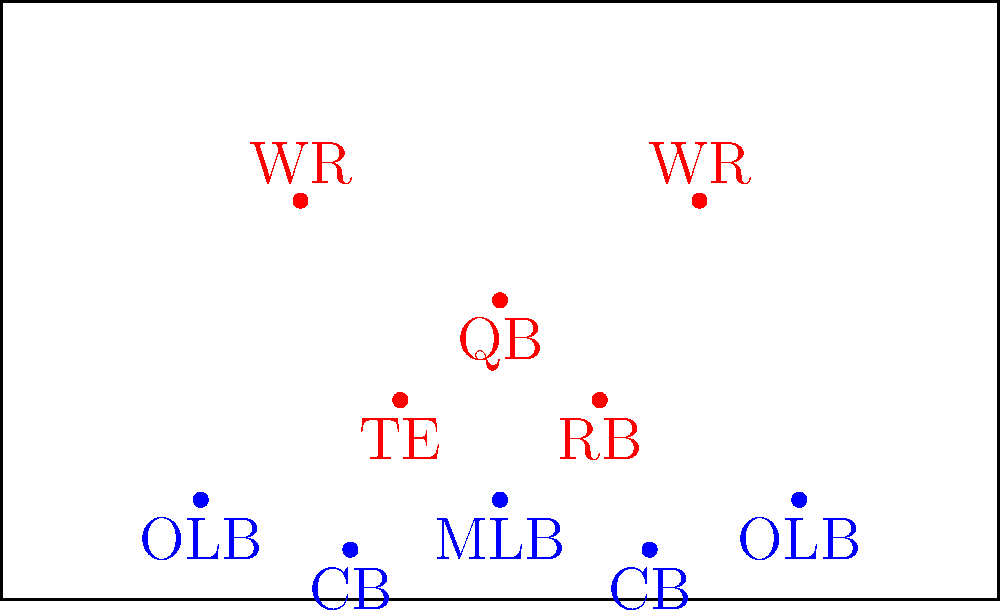Based on the offensive formation shown, which defensive formation would be most effective to counter the spread of receivers and potential run threat? To determine the most effective defensive formation, let's analyze the offensive setup and potential threats:

1. The offense is in a spread formation with 2 wide receivers (WRs), 1 tight end (TE), 1 running back (RB), and the quarterback (QB).

2. This formation presents both passing and running threats:
   - The spread of receivers (2 WRs and 1 TE) suggests a potential passing play.
   - The presence of an RB indicates a possible running play or short pass option.

3. To counter this, we need a formation that can:
   - Cover the spread receivers
   - Maintain gap control for run defense
   - Provide flexibility for blitzing or dropping into coverage

4. The most effective formation would be a nickel defense (5 defensive backs):
   - 2 cornerbacks (CBs) to cover the WRs
   - 1 safety (not shown in the diagram) to cover the TE or provide deep support
   - 2 linebackers (LBs) for run support and short-to-medium pass coverage
   - 4 defensive linemen (not shown) for pass rush and run defense

5. This nickel formation allows:
   - Man-to-man coverage on receivers
   - Zone coverage options
   - Potential for linebacker blitzes
   - Adequate run support with 6 players in the box (4 DL + 2 LB)

Therefore, a nickel defense would be the most effective formation to counter this offensive setup, providing a balance between pass coverage and run defense.
Answer: Nickel defense 